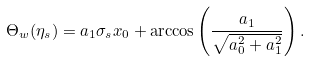Convert formula to latex. <formula><loc_0><loc_0><loc_500><loc_500>\Theta _ { w } ( \eta _ { s } ) = a _ { 1 } \sigma _ { s } x _ { 0 } + \arccos \left ( \frac { a _ { 1 } } { \sqrt { a _ { 0 } ^ { 2 } + a _ { 1 } ^ { 2 } } } \right ) .</formula> 